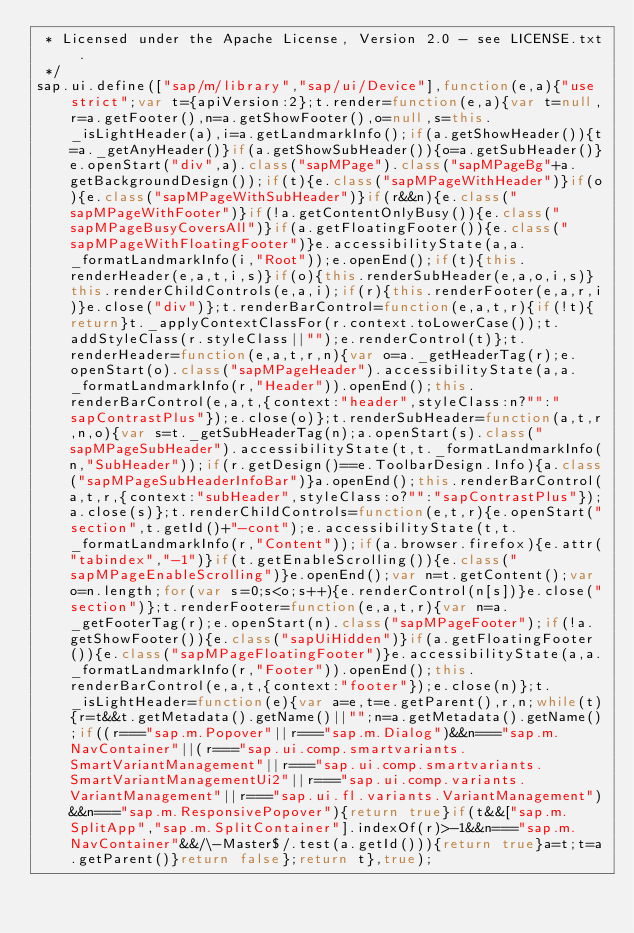Convert code to text. <code><loc_0><loc_0><loc_500><loc_500><_JavaScript_> * Licensed under the Apache License, Version 2.0 - see LICENSE.txt.
 */
sap.ui.define(["sap/m/library","sap/ui/Device"],function(e,a){"use strict";var t={apiVersion:2};t.render=function(e,a){var t=null,r=a.getFooter(),n=a.getShowFooter(),o=null,s=this._isLightHeader(a),i=a.getLandmarkInfo();if(a.getShowHeader()){t=a._getAnyHeader()}if(a.getShowSubHeader()){o=a.getSubHeader()}e.openStart("div",a).class("sapMPage").class("sapMPageBg"+a.getBackgroundDesign());if(t){e.class("sapMPageWithHeader")}if(o){e.class("sapMPageWithSubHeader")}if(r&&n){e.class("sapMPageWithFooter")}if(!a.getContentOnlyBusy()){e.class("sapMPageBusyCoversAll")}if(a.getFloatingFooter()){e.class("sapMPageWithFloatingFooter")}e.accessibilityState(a,a._formatLandmarkInfo(i,"Root"));e.openEnd();if(t){this.renderHeader(e,a,t,i,s)}if(o){this.renderSubHeader(e,a,o,i,s)}this.renderChildControls(e,a,i);if(r){this.renderFooter(e,a,r,i)}e.close("div")};t.renderBarControl=function(e,a,t,r){if(!t){return}t._applyContextClassFor(r.context.toLowerCase());t.addStyleClass(r.styleClass||"");e.renderControl(t)};t.renderHeader=function(e,a,t,r,n){var o=a._getHeaderTag(r);e.openStart(o).class("sapMPageHeader").accessibilityState(a,a._formatLandmarkInfo(r,"Header")).openEnd();this.renderBarControl(e,a,t,{context:"header",styleClass:n?"":"sapContrastPlus"});e.close(o)};t.renderSubHeader=function(a,t,r,n,o){var s=t._getSubHeaderTag(n);a.openStart(s).class("sapMPageSubHeader").accessibilityState(t,t._formatLandmarkInfo(n,"SubHeader"));if(r.getDesign()==e.ToolbarDesign.Info){a.class("sapMPageSubHeaderInfoBar")}a.openEnd();this.renderBarControl(a,t,r,{context:"subHeader",styleClass:o?"":"sapContrastPlus"});a.close(s)};t.renderChildControls=function(e,t,r){e.openStart("section",t.getId()+"-cont");e.accessibilityState(t,t._formatLandmarkInfo(r,"Content"));if(a.browser.firefox){e.attr("tabindex","-1")}if(t.getEnableScrolling()){e.class("sapMPageEnableScrolling")}e.openEnd();var n=t.getContent();var o=n.length;for(var s=0;s<o;s++){e.renderControl(n[s])}e.close("section")};t.renderFooter=function(e,a,t,r){var n=a._getFooterTag(r);e.openStart(n).class("sapMPageFooter");if(!a.getShowFooter()){e.class("sapUiHidden")}if(a.getFloatingFooter()){e.class("sapMPageFloatingFooter")}e.accessibilityState(a,a._formatLandmarkInfo(r,"Footer")).openEnd();this.renderBarControl(e,a,t,{context:"footer"});e.close(n)};t._isLightHeader=function(e){var a=e,t=e.getParent(),r,n;while(t){r=t&&t.getMetadata().getName()||"";n=a.getMetadata().getName();if((r==="sap.m.Popover"||r==="sap.m.Dialog")&&n==="sap.m.NavContainer"||(r==="sap.ui.comp.smartvariants.SmartVariantManagement"||r==="sap.ui.comp.smartvariants.SmartVariantManagementUi2"||r==="sap.ui.comp.variants.VariantManagement"||r==="sap.ui.fl.variants.VariantManagement")&&n==="sap.m.ResponsivePopover"){return true}if(t&&["sap.m.SplitApp","sap.m.SplitContainer"].indexOf(r)>-1&&n==="sap.m.NavContainer"&&/\-Master$/.test(a.getId())){return true}a=t;t=a.getParent()}return false};return t},true);</code> 